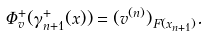<formula> <loc_0><loc_0><loc_500><loc_500>\Phi ^ { + } _ { v } ( \gamma _ { n + 1 } ^ { + } ( x ) ) = ( v ^ { ( n ) } ) _ { F ( x _ { n + 1 } ) } .</formula> 